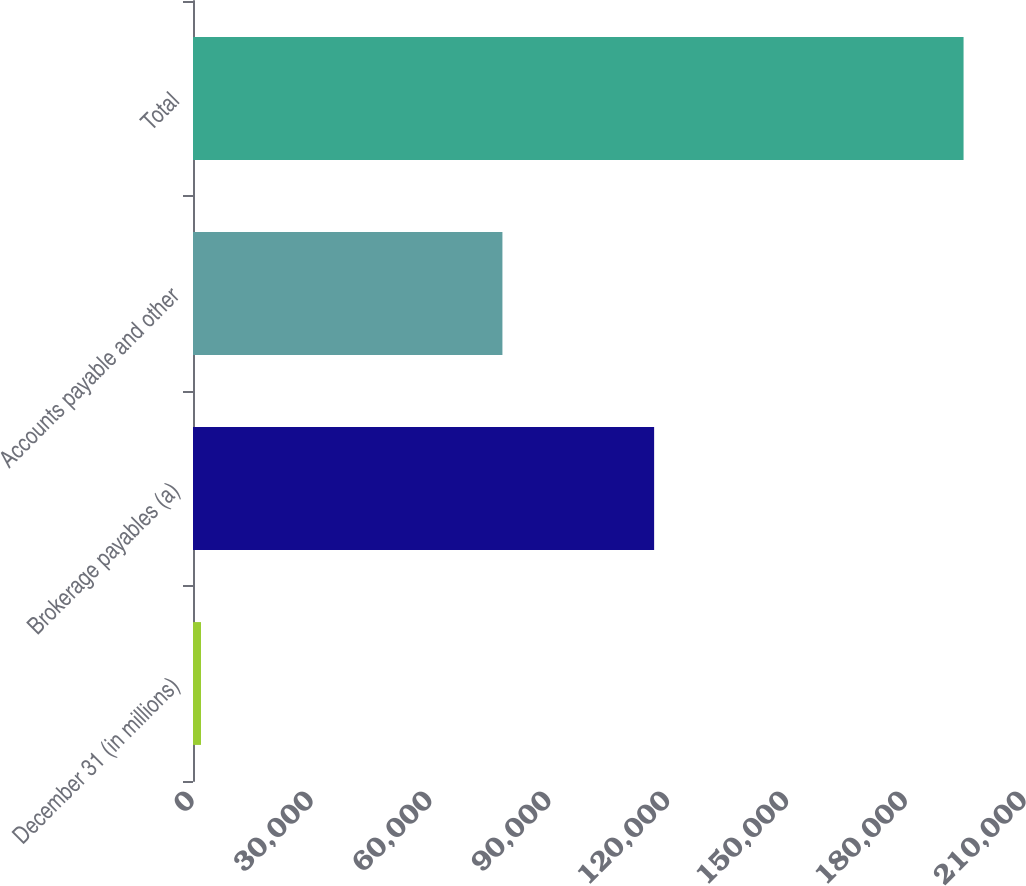<chart> <loc_0><loc_0><loc_500><loc_500><bar_chart><fcel>December 31 (in millions)<fcel>Brokerage payables (a)<fcel>Accounts payable and other<fcel>Total<nl><fcel>2013<fcel>116391<fcel>78100<fcel>194491<nl></chart> 